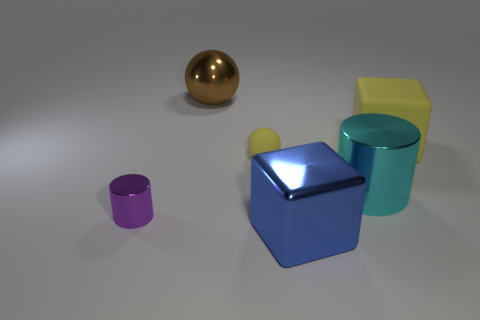There is a small object behind the tiny metallic object; does it have the same color as the cylinder right of the brown sphere?
Provide a short and direct response. No. Is there a large brown rubber thing of the same shape as the blue metal thing?
Provide a short and direct response. No. What number of other objects are there of the same color as the matte block?
Ensure brevity in your answer.  1. There is a thing to the left of the metallic thing that is behind the small thing on the right side of the small cylinder; what is its color?
Ensure brevity in your answer.  Purple. Are there the same number of big yellow cubes behind the rubber cube and big blue metallic blocks?
Make the answer very short. No. Is the size of the sphere that is right of the brown ball the same as the big cyan metal thing?
Make the answer very short. No. What number of blue metal balls are there?
Your response must be concise. 0. How many objects are both in front of the big brown ball and to the left of the blue block?
Provide a short and direct response. 2. Are there any big brown balls that have the same material as the large cyan object?
Keep it short and to the point. Yes. What is the material of the yellow object that is right of the yellow thing that is in front of the large yellow rubber cube?
Give a very brief answer. Rubber. 